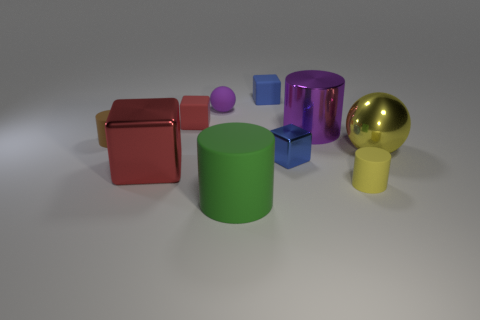How would you describe the overall composition of the image? The image is composed of geometric shapes with various colors and materials, carefully arranged with a clear space between them on a neutral background. What emotions does this image evoke, if any? The image could evoke a sense of order and calm due to the clean arrangement and simplicity of the objects. 